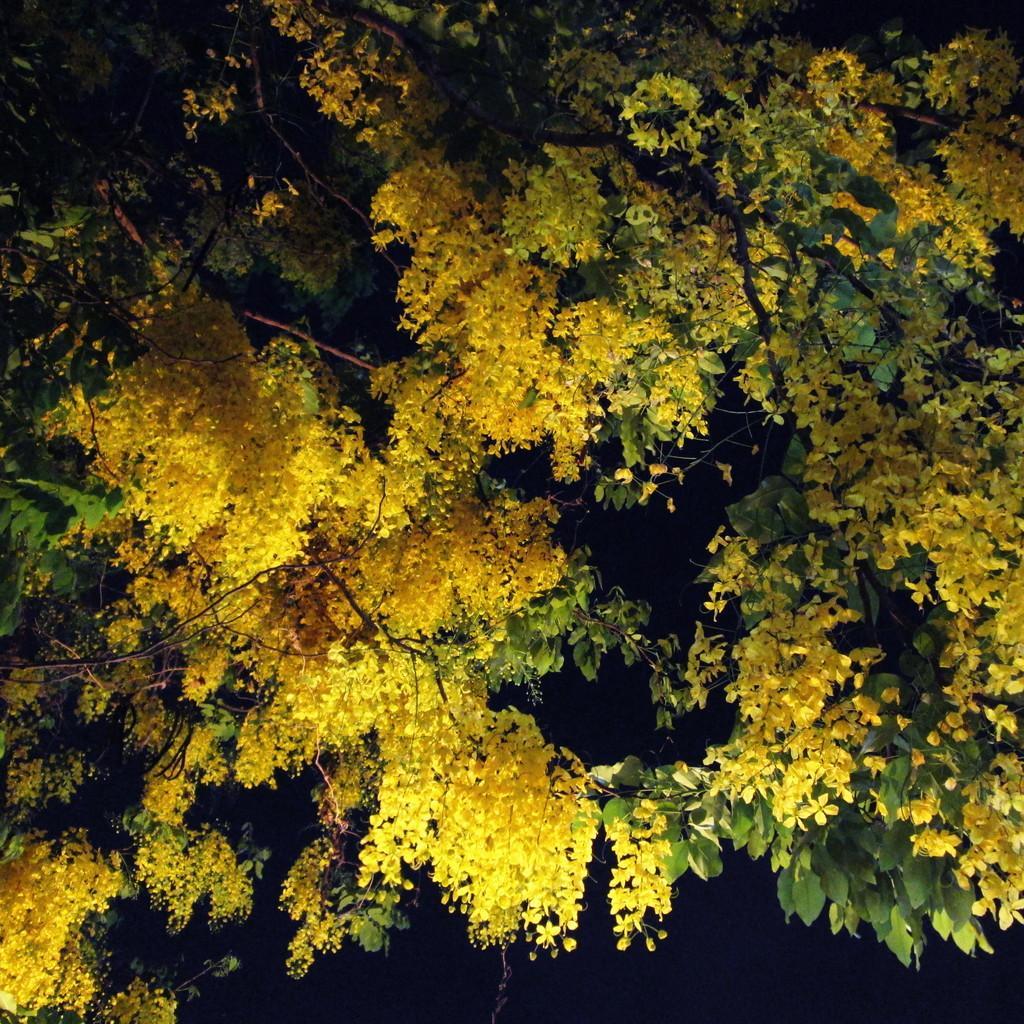In one or two sentences, can you explain what this image depicts? As we can see in the image there are trees, flowers and the image is little dark. 